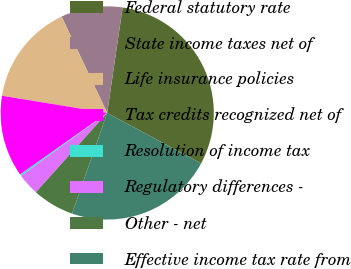<chart> <loc_0><loc_0><loc_500><loc_500><pie_chart><fcel>Federal statutory rate<fcel>State income taxes net of<fcel>Life insurance policies<fcel>Tax credits recognized net of<fcel>Resolution of income tax<fcel>Regulatory differences -<fcel>Other - net<fcel>Effective income tax rate from<nl><fcel>30.53%<fcel>9.34%<fcel>15.39%<fcel>12.37%<fcel>0.26%<fcel>3.29%<fcel>6.31%<fcel>22.5%<nl></chart> 